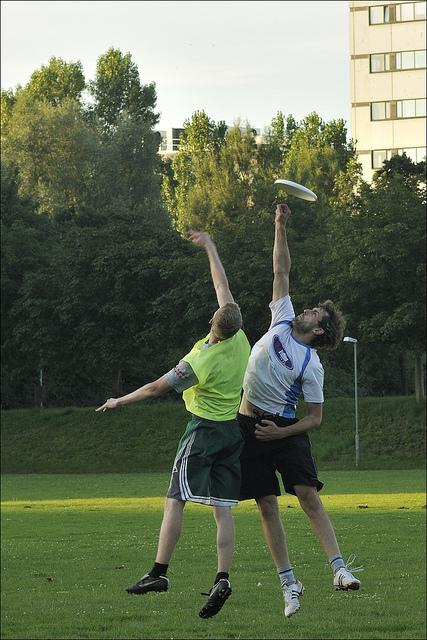What allows this toy to fly? wind 